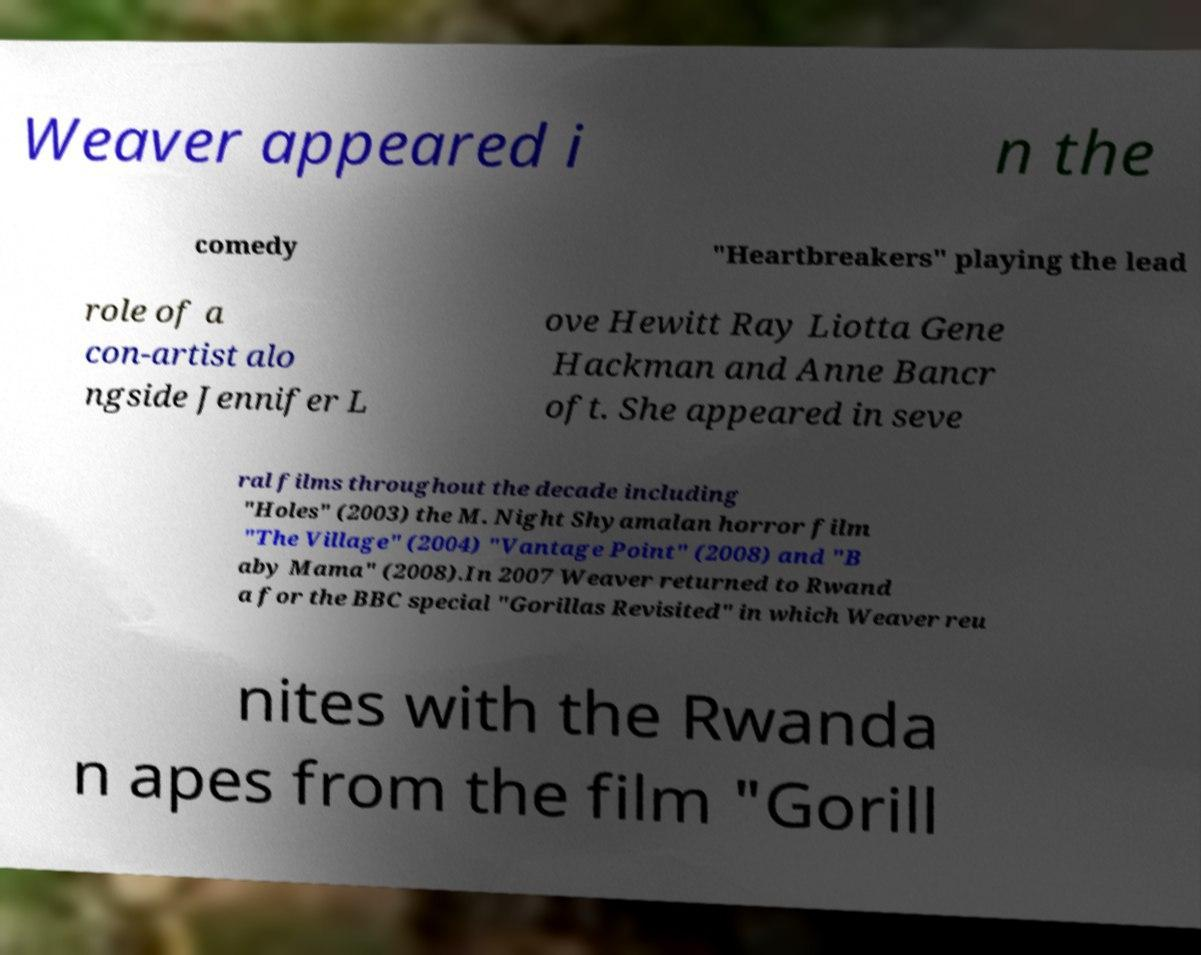Can you accurately transcribe the text from the provided image for me? Weaver appeared i n the comedy "Heartbreakers" playing the lead role of a con-artist alo ngside Jennifer L ove Hewitt Ray Liotta Gene Hackman and Anne Bancr oft. She appeared in seve ral films throughout the decade including "Holes" (2003) the M. Night Shyamalan horror film "The Village" (2004) "Vantage Point" (2008) and "B aby Mama" (2008).In 2007 Weaver returned to Rwand a for the BBC special "Gorillas Revisited" in which Weaver reu nites with the Rwanda n apes from the film "Gorill 